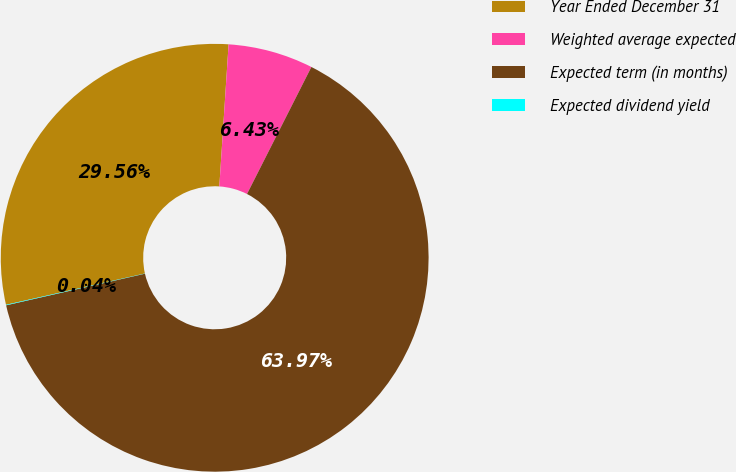<chart> <loc_0><loc_0><loc_500><loc_500><pie_chart><fcel>Year Ended December 31<fcel>Weighted average expected<fcel>Expected term (in months)<fcel>Expected dividend yield<nl><fcel>29.56%<fcel>6.43%<fcel>63.96%<fcel>0.04%<nl></chart> 